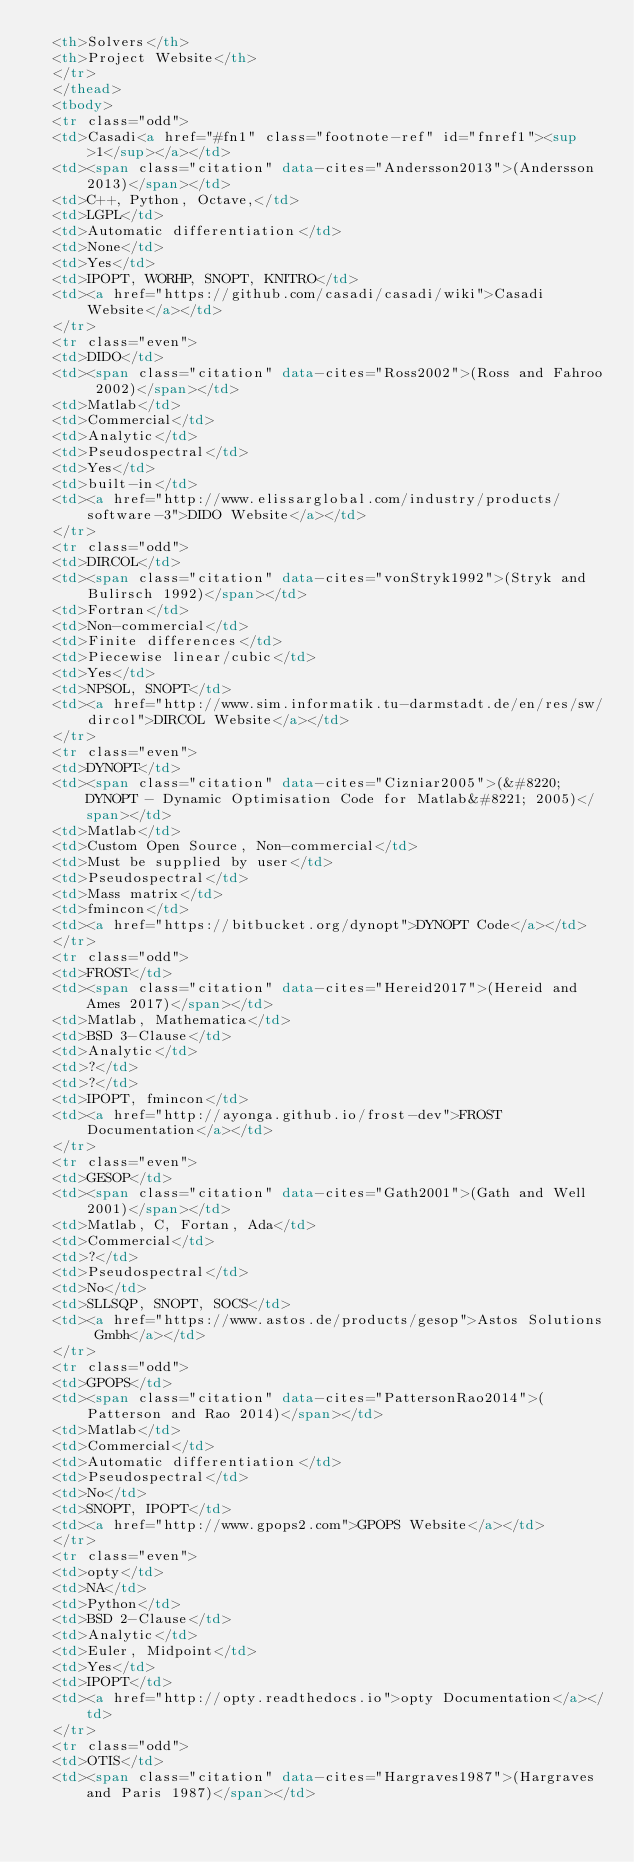Convert code to text. <code><loc_0><loc_0><loc_500><loc_500><_HTML_>  <th>Solvers</th>
  <th>Project Website</th>
  </tr>
  </thead>
  <tbody>
  <tr class="odd">
  <td>Casadi<a href="#fn1" class="footnote-ref" id="fnref1"><sup>1</sup></a></td>
  <td><span class="citation" data-cites="Andersson2013">(Andersson 2013)</span></td>
  <td>C++, Python, Octave,</td>
  <td>LGPL</td>
  <td>Automatic differentiation</td>
  <td>None</td>
  <td>Yes</td>
  <td>IPOPT, WORHP, SNOPT, KNITRO</td>
  <td><a href="https://github.com/casadi/casadi/wiki">Casadi Website</a></td>
  </tr>
  <tr class="even">
  <td>DIDO</td>
  <td><span class="citation" data-cites="Ross2002">(Ross and Fahroo 2002)</span></td>
  <td>Matlab</td>
  <td>Commercial</td>
  <td>Analytic</td>
  <td>Pseudospectral</td>
  <td>Yes</td>
  <td>built-in</td>
  <td><a href="http://www.elissarglobal.com/industry/products/software-3">DIDO Website</a></td>
  </tr>
  <tr class="odd">
  <td>DIRCOL</td>
  <td><span class="citation" data-cites="vonStryk1992">(Stryk and Bulirsch 1992)</span></td>
  <td>Fortran</td>
  <td>Non-commercial</td>
  <td>Finite differences</td>
  <td>Piecewise linear/cubic</td>
  <td>Yes</td>
  <td>NPSOL, SNOPT</td>
  <td><a href="http://www.sim.informatik.tu-darmstadt.de/en/res/sw/dircol">DIRCOL Website</a></td>
  </tr>
  <tr class="even">
  <td>DYNOPT</td>
  <td><span class="citation" data-cites="Cizniar2005">(&#8220;DYNOPT - Dynamic Optimisation Code for Matlab&#8221; 2005)</span></td>
  <td>Matlab</td>
  <td>Custom Open Source, Non-commercial</td>
  <td>Must be supplied by user</td>
  <td>Pseudospectral</td>
  <td>Mass matrix</td>
  <td>fmincon</td>
  <td><a href="https://bitbucket.org/dynopt">DYNOPT Code</a></td>
  </tr>
  <tr class="odd">
  <td>FROST</td>
  <td><span class="citation" data-cites="Hereid2017">(Hereid and Ames 2017)</span></td>
  <td>Matlab, Mathematica</td>
  <td>BSD 3-Clause</td>
  <td>Analytic</td>
  <td>?</td>
  <td>?</td>
  <td>IPOPT, fmincon</td>
  <td><a href="http://ayonga.github.io/frost-dev">FROST Documentation</a></td>
  </tr>
  <tr class="even">
  <td>GESOP</td>
  <td><span class="citation" data-cites="Gath2001">(Gath and Well 2001)</span></td>
  <td>Matlab, C, Fortan, Ada</td>
  <td>Commercial</td>
  <td>?</td>
  <td>Pseudospectral</td>
  <td>No</td>
  <td>SLLSQP, SNOPT, SOCS</td>
  <td><a href="https://www.astos.de/products/gesop">Astos Solutions Gmbh</a></td>
  </tr>
  <tr class="odd">
  <td>GPOPS</td>
  <td><span class="citation" data-cites="PattersonRao2014">(Patterson and Rao 2014)</span></td>
  <td>Matlab</td>
  <td>Commercial</td>
  <td>Automatic differentiation</td>
  <td>Pseudospectral</td>
  <td>No</td>
  <td>SNOPT, IPOPT</td>
  <td><a href="http://www.gpops2.com">GPOPS Website</a></td>
  </tr>
  <tr class="even">
  <td>opty</td>
  <td>NA</td>
  <td>Python</td>
  <td>BSD 2-Clause</td>
  <td>Analytic</td>
  <td>Euler, Midpoint</td>
  <td>Yes</td>
  <td>IPOPT</td>
  <td><a href="http://opty.readthedocs.io">opty Documentation</a></td>
  </tr>
  <tr class="odd">
  <td>OTIS</td>
  <td><span class="citation" data-cites="Hargraves1987">(Hargraves and Paris 1987)</span></td></code> 